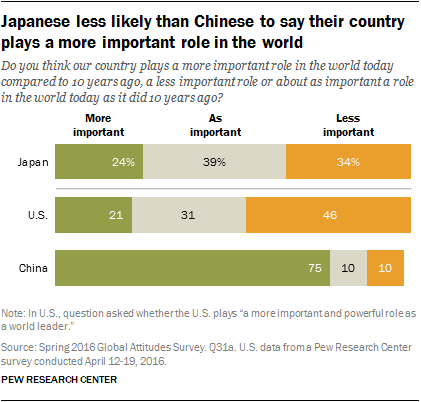Mention a couple of crucial points in this snapshot. In China, the ratio between less important and more important is approximately 0.13333... Orange data represents a lower level of importance compared to other data. 